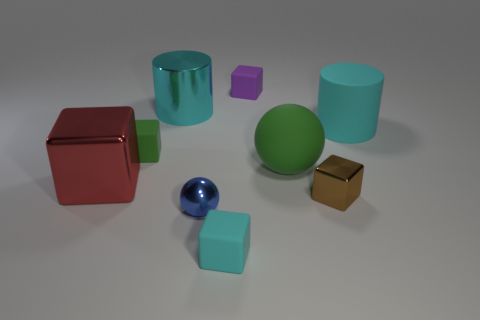Subtract all tiny metallic cubes. How many cubes are left? 4 Subtract all blue spheres. How many spheres are left? 1 Subtract all cylinders. How many objects are left? 7 Add 1 red cubes. How many objects exist? 10 Subtract 3 blocks. How many blocks are left? 2 Add 4 red metal objects. How many red metal objects are left? 5 Add 1 big brown rubber things. How many big brown rubber things exist? 1 Subtract 0 red spheres. How many objects are left? 9 Subtract all brown balls. Subtract all gray blocks. How many balls are left? 2 Subtract all brown cylinders. How many purple blocks are left? 1 